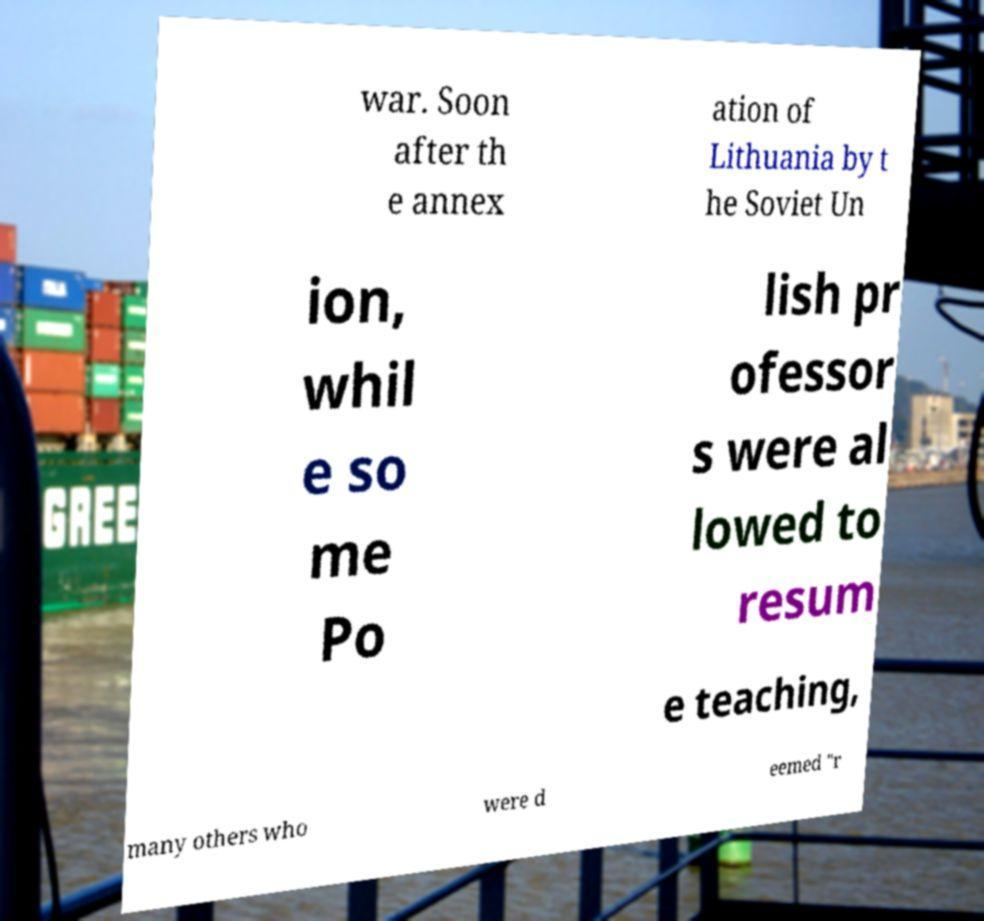Please read and relay the text visible in this image. What does it say? war. Soon after th e annex ation of Lithuania by t he Soviet Un ion, whil e so me Po lish pr ofessor s were al lowed to resum e teaching, many others who were d eemed "r 